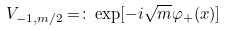<formula> <loc_0><loc_0><loc_500><loc_500>V _ { - 1 , m / 2 } = \colon \exp [ - i \sqrt { m } \varphi _ { + } ( x ) ]</formula> 